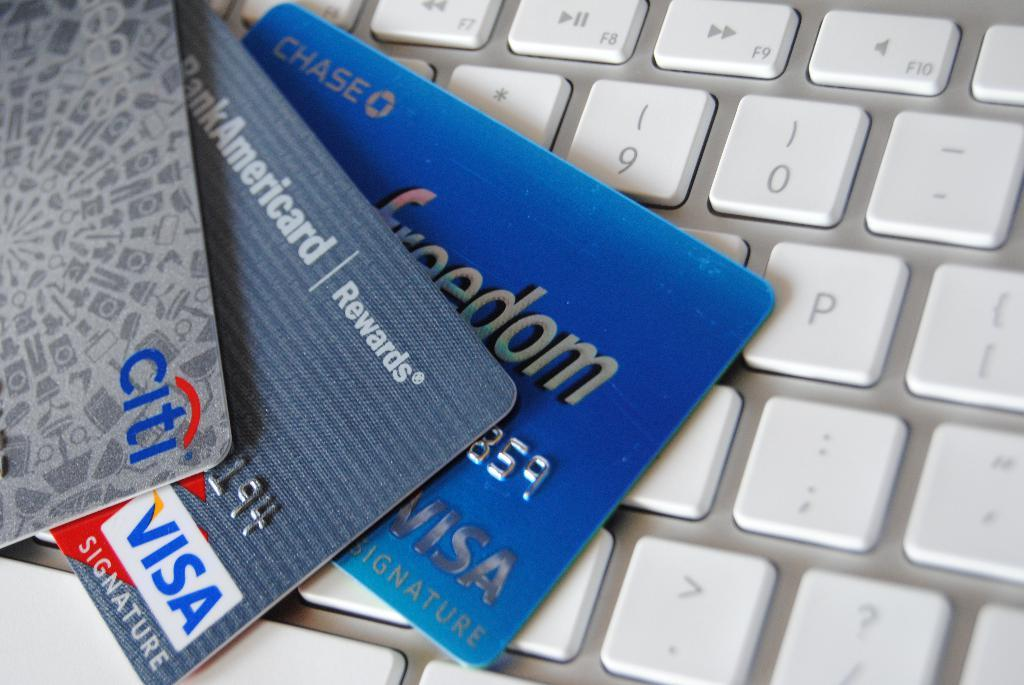<image>
Provide a brief description of the given image. Three cards, including a chase freedom card are on a keyboard. 